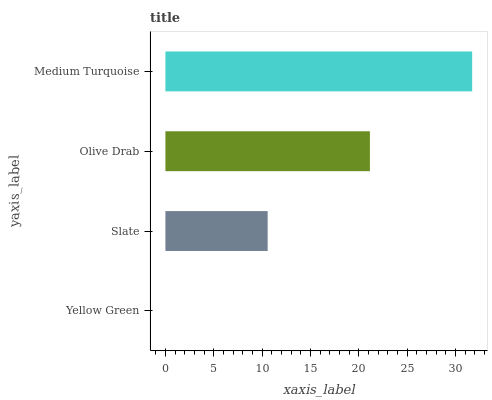Is Yellow Green the minimum?
Answer yes or no. Yes. Is Medium Turquoise the maximum?
Answer yes or no. Yes. Is Slate the minimum?
Answer yes or no. No. Is Slate the maximum?
Answer yes or no. No. Is Slate greater than Yellow Green?
Answer yes or no. Yes. Is Yellow Green less than Slate?
Answer yes or no. Yes. Is Yellow Green greater than Slate?
Answer yes or no. No. Is Slate less than Yellow Green?
Answer yes or no. No. Is Olive Drab the high median?
Answer yes or no. Yes. Is Slate the low median?
Answer yes or no. Yes. Is Medium Turquoise the high median?
Answer yes or no. No. Is Yellow Green the low median?
Answer yes or no. No. 